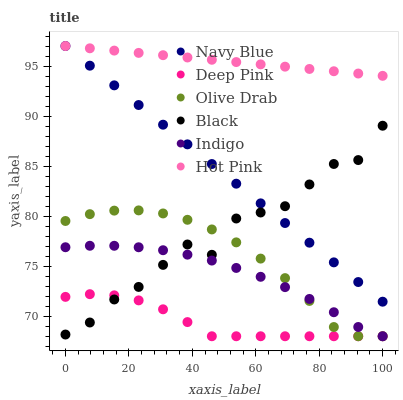Does Deep Pink have the minimum area under the curve?
Answer yes or no. Yes. Does Hot Pink have the maximum area under the curve?
Answer yes or no. Yes. Does Indigo have the minimum area under the curve?
Answer yes or no. No. Does Indigo have the maximum area under the curve?
Answer yes or no. No. Is Navy Blue the smoothest?
Answer yes or no. Yes. Is Black the roughest?
Answer yes or no. Yes. Is Indigo the smoothest?
Answer yes or no. No. Is Indigo the roughest?
Answer yes or no. No. Does Deep Pink have the lowest value?
Answer yes or no. Yes. Does Navy Blue have the lowest value?
Answer yes or no. No. Does Hot Pink have the highest value?
Answer yes or no. Yes. Does Indigo have the highest value?
Answer yes or no. No. Is Indigo less than Navy Blue?
Answer yes or no. Yes. Is Hot Pink greater than Olive Drab?
Answer yes or no. Yes. Does Indigo intersect Olive Drab?
Answer yes or no. Yes. Is Indigo less than Olive Drab?
Answer yes or no. No. Is Indigo greater than Olive Drab?
Answer yes or no. No. Does Indigo intersect Navy Blue?
Answer yes or no. No. 